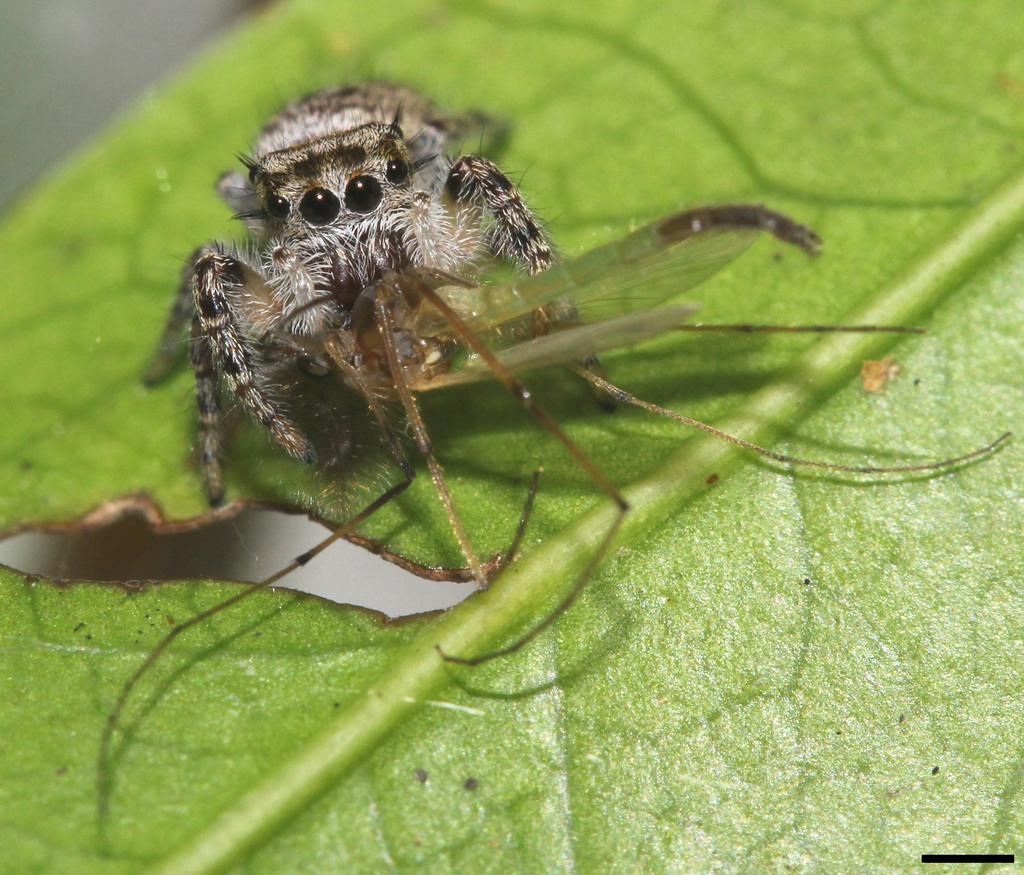What is present on the leaf in the image? There is an insect on the leaf in the image. Can you describe the insect's location on the leaf? The insect is on the leaf in the image. What type of tax is being discussed on the stage in the image? There is no stage, tax, or discussion present in the image; it features an insect on a leaf. 